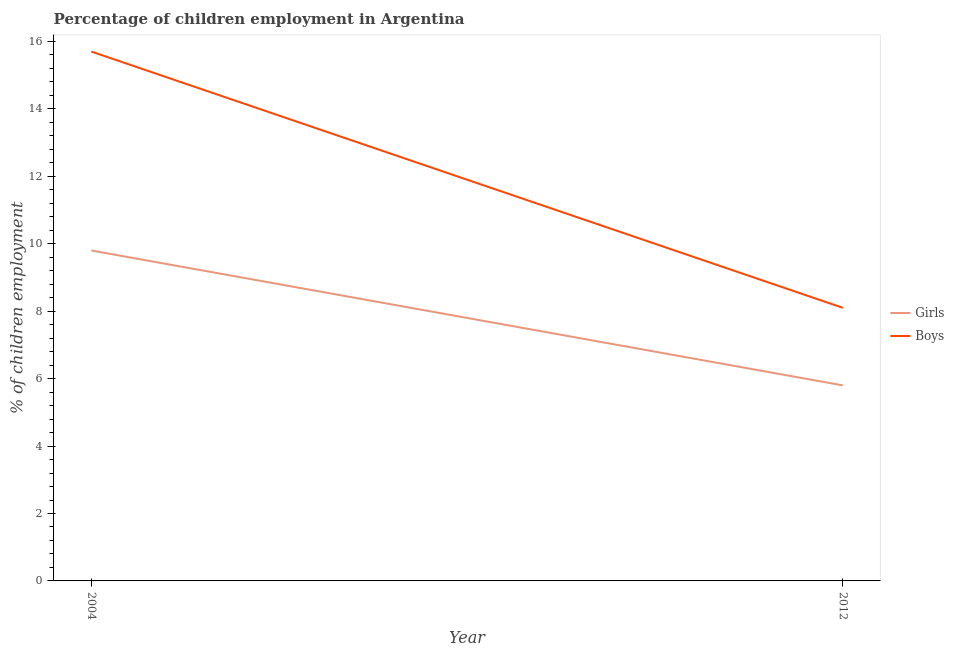How many different coloured lines are there?
Provide a succinct answer. 2. Across all years, what is the maximum percentage of employed boys?
Offer a terse response. 15.7. Across all years, what is the minimum percentage of employed boys?
Your response must be concise. 8.1. What is the total percentage of employed boys in the graph?
Give a very brief answer. 23.8. What is the difference between the percentage of employed boys in 2004 and the percentage of employed girls in 2012?
Ensure brevity in your answer.  9.9. What is the average percentage of employed boys per year?
Keep it short and to the point. 11.9. In the year 2004, what is the difference between the percentage of employed girls and percentage of employed boys?
Keep it short and to the point. -5.9. In how many years, is the percentage of employed boys greater than 5.2 %?
Provide a short and direct response. 2. What is the ratio of the percentage of employed girls in 2004 to that in 2012?
Make the answer very short. 1.69. Is the percentage of employed girls in 2004 less than that in 2012?
Your answer should be very brief. No. In how many years, is the percentage of employed girls greater than the average percentage of employed girls taken over all years?
Your answer should be compact. 1. Does the percentage of employed girls monotonically increase over the years?
Provide a short and direct response. No. How many lines are there?
Provide a short and direct response. 2. What is the difference between two consecutive major ticks on the Y-axis?
Make the answer very short. 2. Are the values on the major ticks of Y-axis written in scientific E-notation?
Your response must be concise. No. How many legend labels are there?
Your response must be concise. 2. How are the legend labels stacked?
Offer a very short reply. Vertical. What is the title of the graph?
Your answer should be compact. Percentage of children employment in Argentina. What is the label or title of the X-axis?
Give a very brief answer. Year. What is the label or title of the Y-axis?
Give a very brief answer. % of children employment. What is the % of children employment of Girls in 2004?
Provide a succinct answer. 9.8. What is the % of children employment in Boys in 2012?
Make the answer very short. 8.1. Across all years, what is the maximum % of children employment of Boys?
Your answer should be compact. 15.7. Across all years, what is the minimum % of children employment of Girls?
Your response must be concise. 5.8. Across all years, what is the minimum % of children employment of Boys?
Give a very brief answer. 8.1. What is the total % of children employment of Girls in the graph?
Give a very brief answer. 15.6. What is the total % of children employment of Boys in the graph?
Offer a very short reply. 23.8. What is the difference between the % of children employment of Girls in 2004 and that in 2012?
Your answer should be very brief. 4. What is the average % of children employment of Girls per year?
Your response must be concise. 7.8. What is the average % of children employment of Boys per year?
Provide a succinct answer. 11.9. In the year 2012, what is the difference between the % of children employment of Girls and % of children employment of Boys?
Make the answer very short. -2.3. What is the ratio of the % of children employment in Girls in 2004 to that in 2012?
Your answer should be very brief. 1.69. What is the ratio of the % of children employment in Boys in 2004 to that in 2012?
Ensure brevity in your answer.  1.94. What is the difference between the highest and the second highest % of children employment in Boys?
Offer a terse response. 7.6. What is the difference between the highest and the lowest % of children employment in Boys?
Make the answer very short. 7.6. 